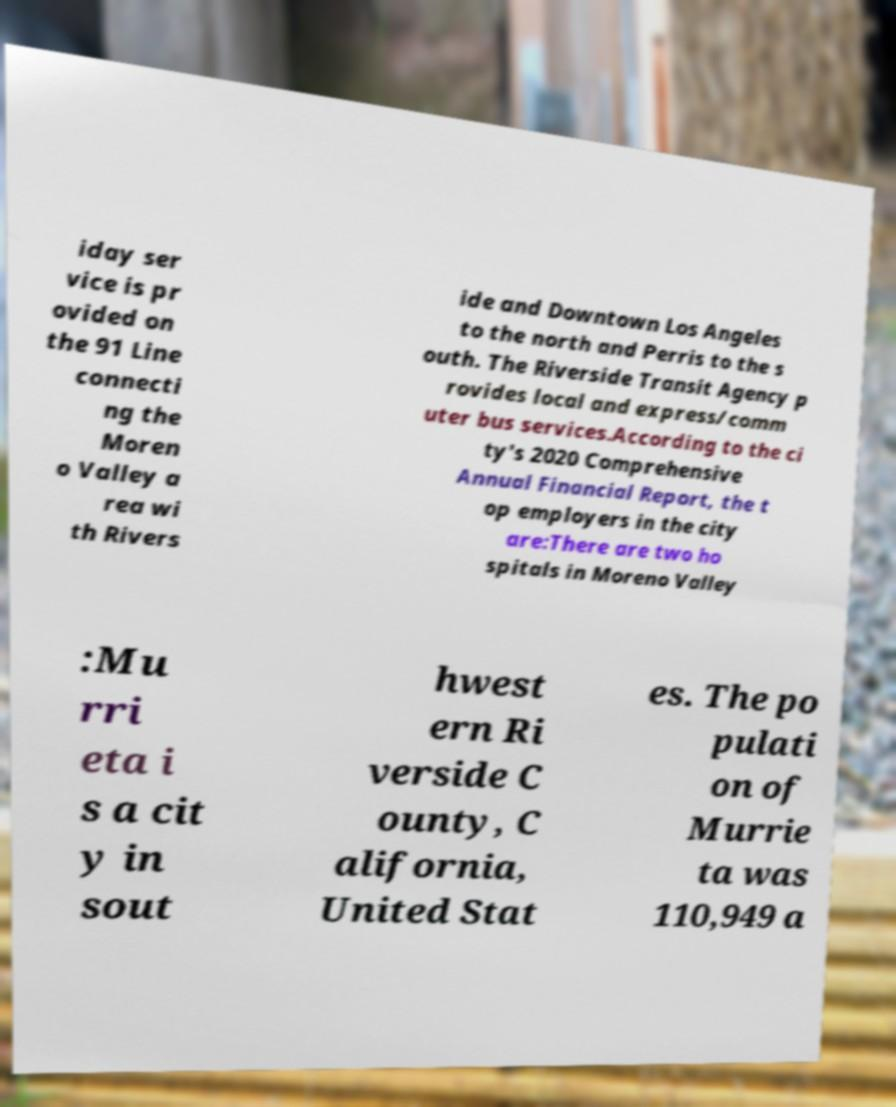What messages or text are displayed in this image? I need them in a readable, typed format. iday ser vice is pr ovided on the 91 Line connecti ng the Moren o Valley a rea wi th Rivers ide and Downtown Los Angeles to the north and Perris to the s outh. The Riverside Transit Agency p rovides local and express/comm uter bus services.According to the ci ty's 2020 Comprehensive Annual Financial Report, the t op employers in the city are:There are two ho spitals in Moreno Valley :Mu rri eta i s a cit y in sout hwest ern Ri verside C ounty, C alifornia, United Stat es. The po pulati on of Murrie ta was 110,949 a 